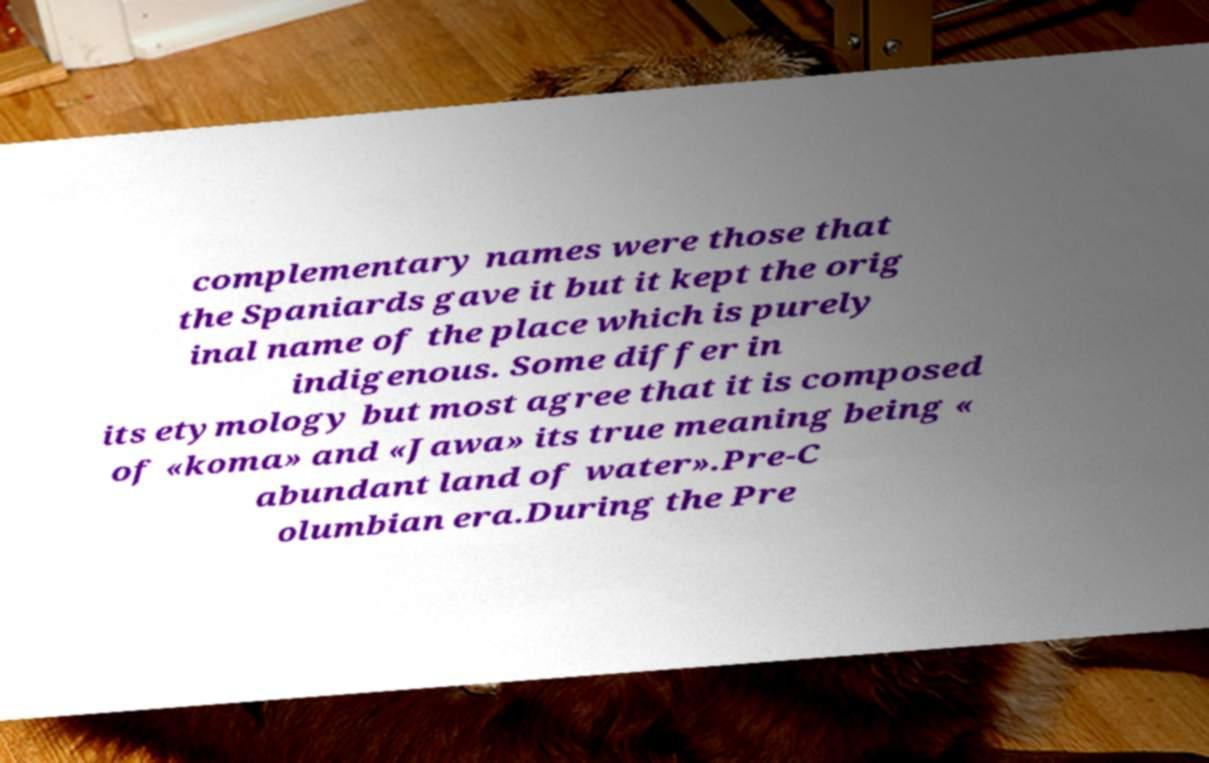Could you extract and type out the text from this image? complementary names were those that the Spaniards gave it but it kept the orig inal name of the place which is purely indigenous. Some differ in its etymology but most agree that it is composed of «koma» and «Jawa» its true meaning being « abundant land of water».Pre-C olumbian era.During the Pre 